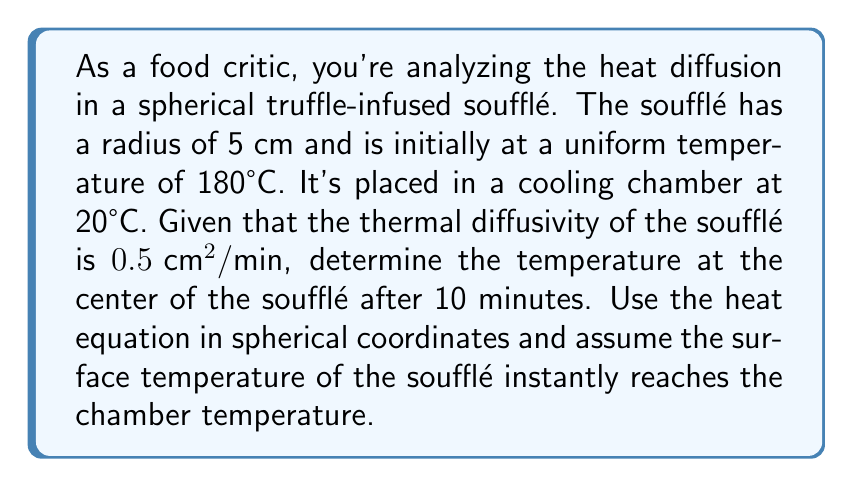Give your solution to this math problem. To solve this problem, we'll use the heat equation in spherical coordinates and apply the separation of variables method.

1) The heat equation in spherical coordinates with radial symmetry is:

   $$\frac{\partial T}{\partial t} = \alpha \left(\frac{\partial^2 T}{\partial r^2} + \frac{2}{r}\frac{\partial T}{\partial r}\right)$$

   where $\alpha$ is the thermal diffusivity.

2) The boundary conditions are:
   $T(r,0) = 180°C$ for $0 \leq r < 5$
   $T(5,t) = 20°C$ for $t > 0$

3) The solution for this problem is:

   $$T(r,t) = 20 + \frac{2a}{r\pi}\sum_{n=1}^{\infty}\frac{(-1)^{n+1}}{n}\sin\left(\frac{n\pi r}{a}\right)e^{-\alpha n^2\pi^2t/a^2}$$

   where $a$ is the radius of the sphere.

4) For the center of the soufflé, $r = 0$. As $r$ approaches 0, $\sin(n\pi r/a)/(r\pi)$ approaches $n/a$. So at the center:

   $$T(0,t) = 20 + 2\sum_{n=1}^{\infty}(-1)^{n+1}e^{-\alpha n^2\pi^2t/a^2}$$

5) Substituting the values:
   $\alpha = 0.5 \text{ cm}^2/\text{min}$
   $a = 5 \text{ cm}$
   $t = 10 \text{ min}$

   $$T(0,10) = 20 + 2\sum_{n=1}^{\infty}(-1)^{n+1}e^{-0.5n^2\pi^2(10)/5^2}$$

6) Calculate the first few terms of the series:
   $n=1: 2e^{-0.2\pi^2} \approx 0.7477$
   $n=2: -2e^{-0.8\pi^2} \approx -0.0003$
   $n=3: 2e^{-1.8\pi^2} \approx 0.0000$

   The series converges rapidly, so we can stop here.

7) Adding these terms to 20°C:
   $T(0,10) \approx 20 + 0.7477 - 0.0003 = 20.7474°C$
Answer: The temperature at the center of the soufflé after 10 minutes is approximately 20.75°C. 